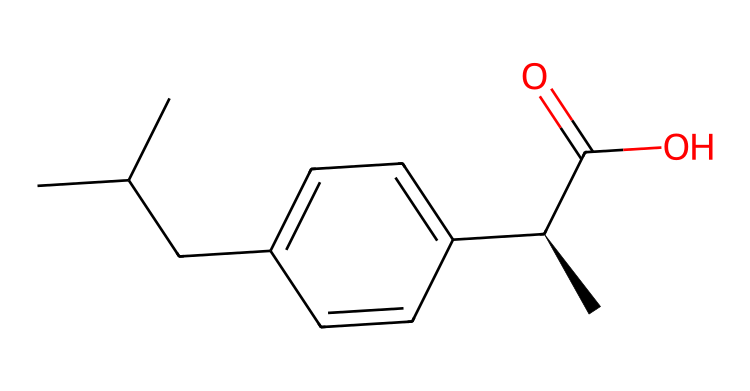What is the molecular formula of ibuprofen? The molecular formula can be determined by counting the number of each type of atom in the SMILES representation. In this case, there are 13 carbon atoms, 18 hydrogen atoms, and 2 oxygen atoms, leading to a molecular formula of C13H18O2.
Answer: C13H18O2 How many rings are present in the ibuprofen structure? By examining the SMILES representation, we note that there are no cyclic structures indicated (there are no numbers to denote ring closures), so ibuprofen has 0 rings.
Answer: 0 What functional group is present in ibuprofen? The SMILES includes a "C(=O)O" which represents a carboxylic acid functional group (the carbonyl adjacent to a hydroxyl group), indicating the presence of this specific functional group.
Answer: carboxylic acid How many stereocenters does ibuprofen have? A stereocenter is a carbon atom bonded to four different groups. In the SMILES string, the notation "[C@H]" indicates that there is one stereochemical center due to the configuration of the carbon atom indicated with @.
Answer: 1 What type of isomerism can ibuprofen exhibit? Because ibuprofen contains a stereocenter, it can exhibit stereoisomerism. The presence of one chiral center allows for two enantiomers (mirror images).
Answer: stereoisomerism What is the role of the -COOH group in ibuprofen? The -COOH group, indicative of the carboxylic acid functional group, is responsible for the drug's acidity and contributes to its analgesic properties in pain relief by mediating inflammation processes.
Answer: analgesic properties How many total atoms are in the ibuprofen molecule? To find the total number of atoms, sum the numbers of carbon (13), hydrogen (18), and oxygen (2) atoms: 13 + 18 + 2 equals 33. Hence, there are 33 atoms in total.
Answer: 33 